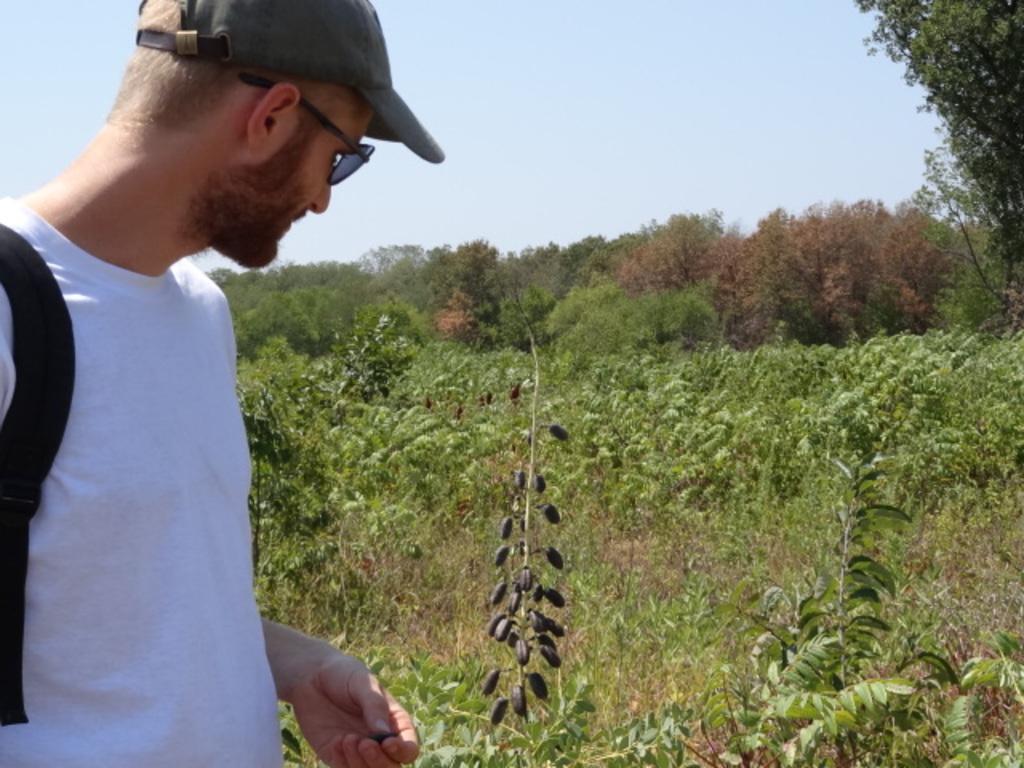Could you give a brief overview of what you see in this image? The man on the left side who is wearing the white T-shirt and bag is standing. He is wearing the goggles and a cap. Beside him, we see plants which have black color seeds. There are plants and trees in the background. At the top, we see the sky. 